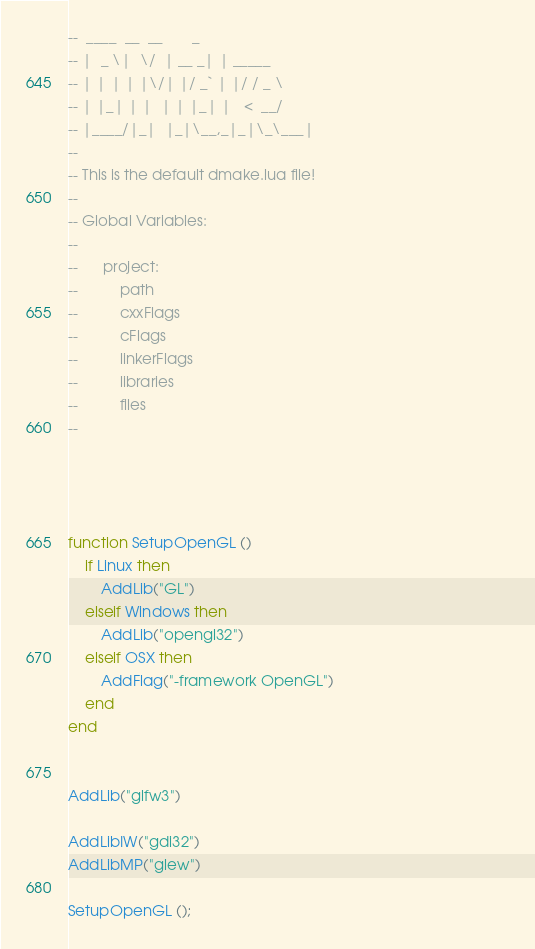<code> <loc_0><loc_0><loc_500><loc_500><_Lua_>--  ____  __  __       _        
-- |  _ \|  \/  | __ _| | _____ 
-- | | | | |\/| |/ _` | |/ / _ \
-- | |_| | |  | | |_| |   <  __/
-- |____/|_|  |_|\__,_|_|\_\___|
--
-- This is the default dmake.lua file!
--
-- Global Variables:
--		
--		project:
--			path
--			cxxFlags
--			cFlags
--			linkerFlags
--			libraries
--			files
--



                                                                                                          
function SetupOpenGL ()
	if Linux then
		AddLib("GL")
	elseif Windows then
		AddLib("opengl32")
	elseif OSX then
		AddFlag("-framework OpenGL")
	end
end


AddLib("glfw3")

AddLibIW("gdi32")
AddLibMP("glew")

SetupOpenGL ();</code> 